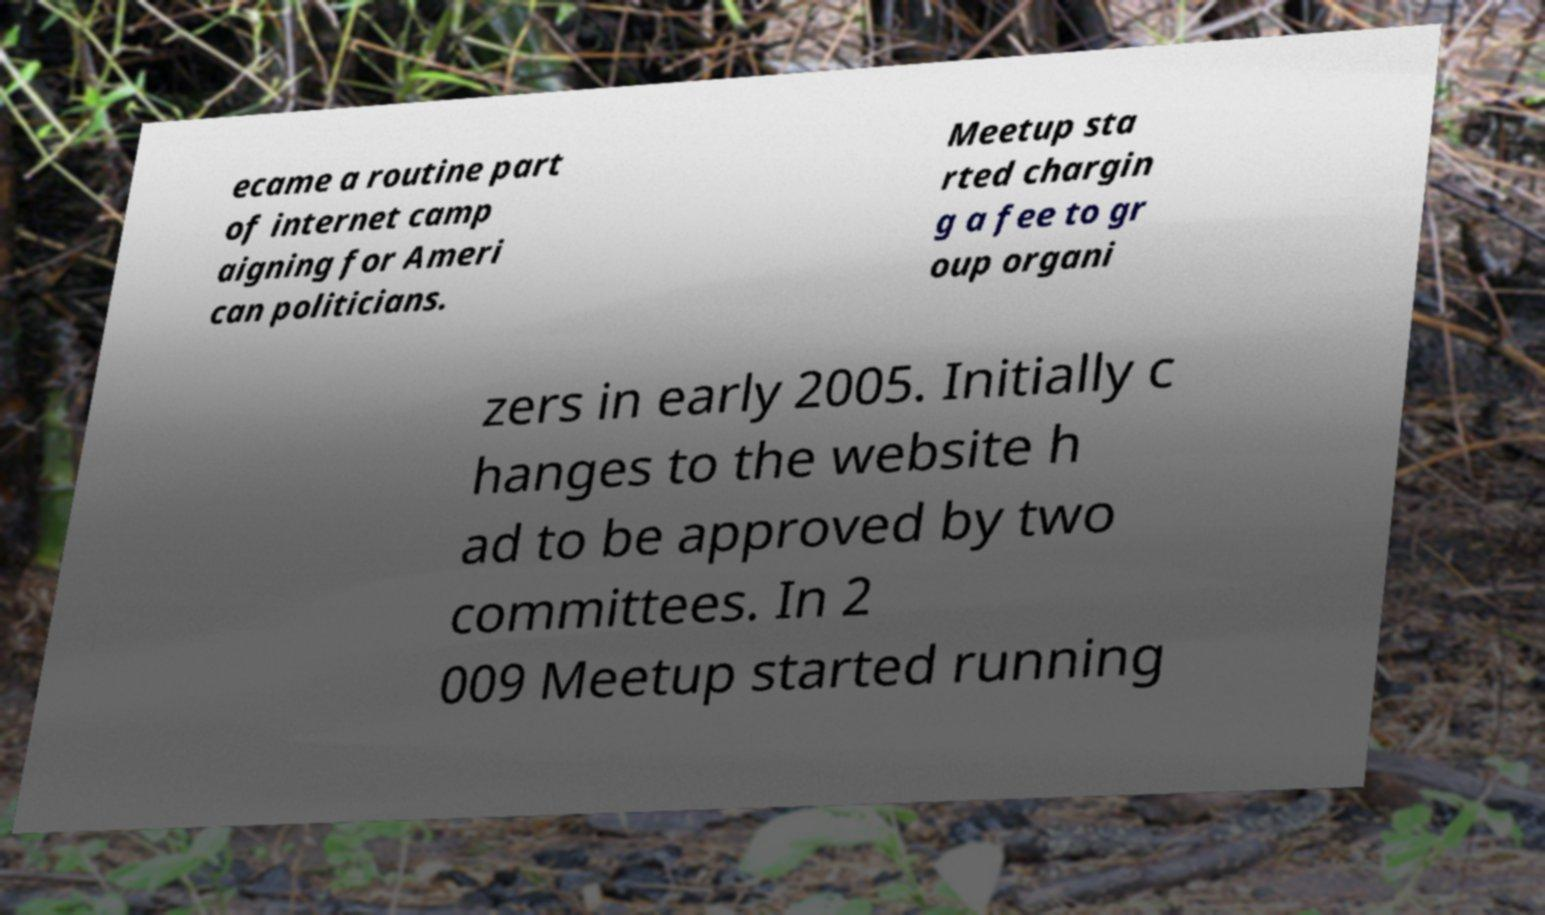Can you read and provide the text displayed in the image?This photo seems to have some interesting text. Can you extract and type it out for me? ecame a routine part of internet camp aigning for Ameri can politicians. Meetup sta rted chargin g a fee to gr oup organi zers in early 2005. Initially c hanges to the website h ad to be approved by two committees. In 2 009 Meetup started running 